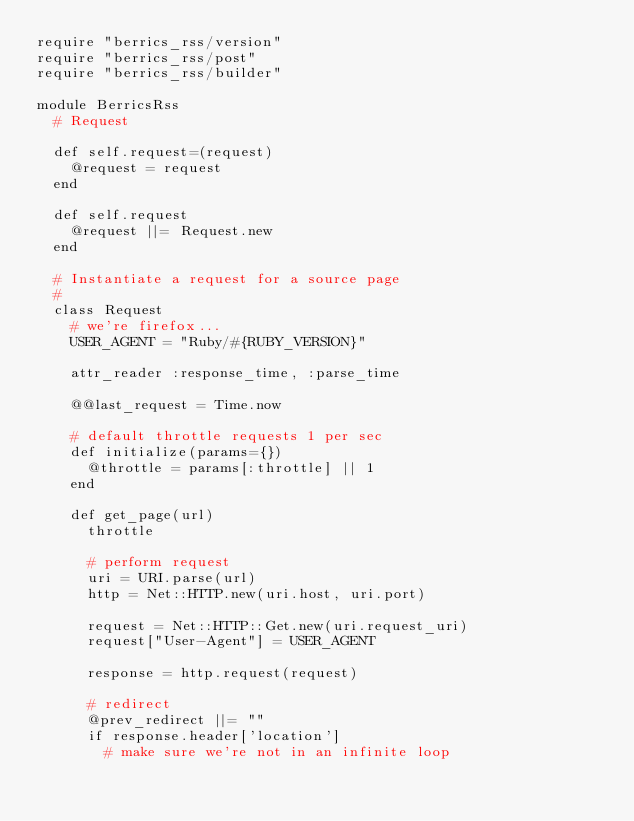Convert code to text. <code><loc_0><loc_0><loc_500><loc_500><_Ruby_>require "berrics_rss/version"
require "berrics_rss/post"
require "berrics_rss/builder"

module BerricsRss
  # Request

  def self.request=(request)
    @request = request
  end

  def self.request
    @request ||= Request.new
  end
  
  # Instantiate a request for a source page
  #
  class Request
    # we're firefox...
    USER_AGENT = "Ruby/#{RUBY_VERSION}"
    
    attr_reader :response_time, :parse_time

    @@last_request = Time.now

    # default throttle requests 1 per sec
    def initialize(params={})
      @throttle = params[:throttle] || 1
    end

    def get_page(url)
      throttle

      # perform request
      uri = URI.parse(url)
      http = Net::HTTP.new(uri.host, uri.port)

      request = Net::HTTP::Get.new(uri.request_uri)
      request["User-Agent"] = USER_AGENT

      response = http.request(request)

      # redirect
      @prev_redirect ||= ""
      if response.header['location']
        # make sure we're not in an infinite loop</code> 